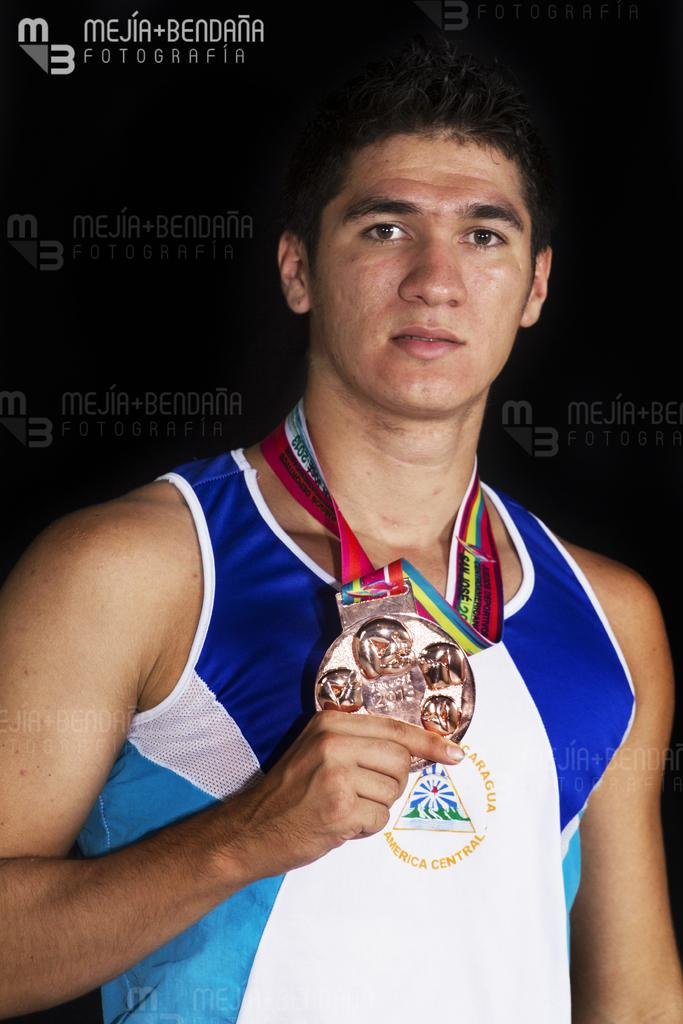Who is present in the image? There is a man in the image. What is the man wearing in the image? The man is wearing a medal in the image. What is the man doing with the medal? The man is holding the medal in the image. What else can be seen in the image besides the man and the medal? There is text visible in the image. What type of cattle can be seen grazing in the image? There is no cattle present in the image; it features a man holding a medal and text. How does the man's growth affect the image? The man's growth is not mentioned in the image, and therefore its impact cannot be determined. 